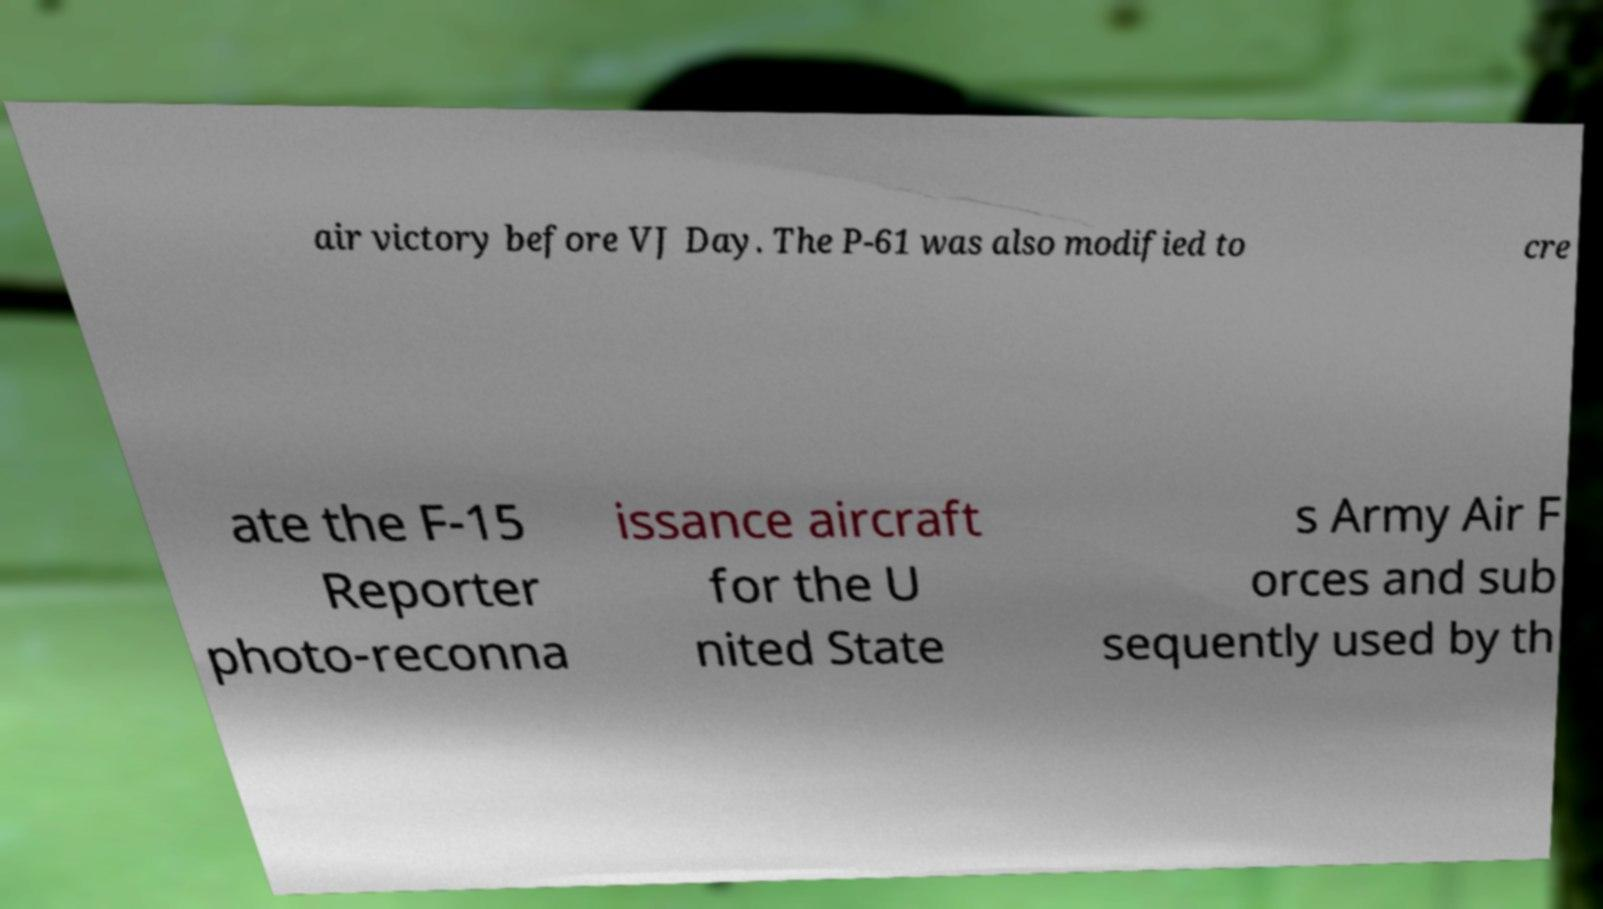What messages or text are displayed in this image? I need them in a readable, typed format. air victory before VJ Day. The P-61 was also modified to cre ate the F-15 Reporter photo-reconna issance aircraft for the U nited State s Army Air F orces and sub sequently used by th 